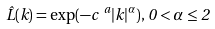Convert formula to latex. <formula><loc_0><loc_0><loc_500><loc_500>\hat { L } ( k ) = \exp ( - c ^ { \ a } | k | ^ { \alpha } ) , \, 0 < \alpha \leq 2</formula> 